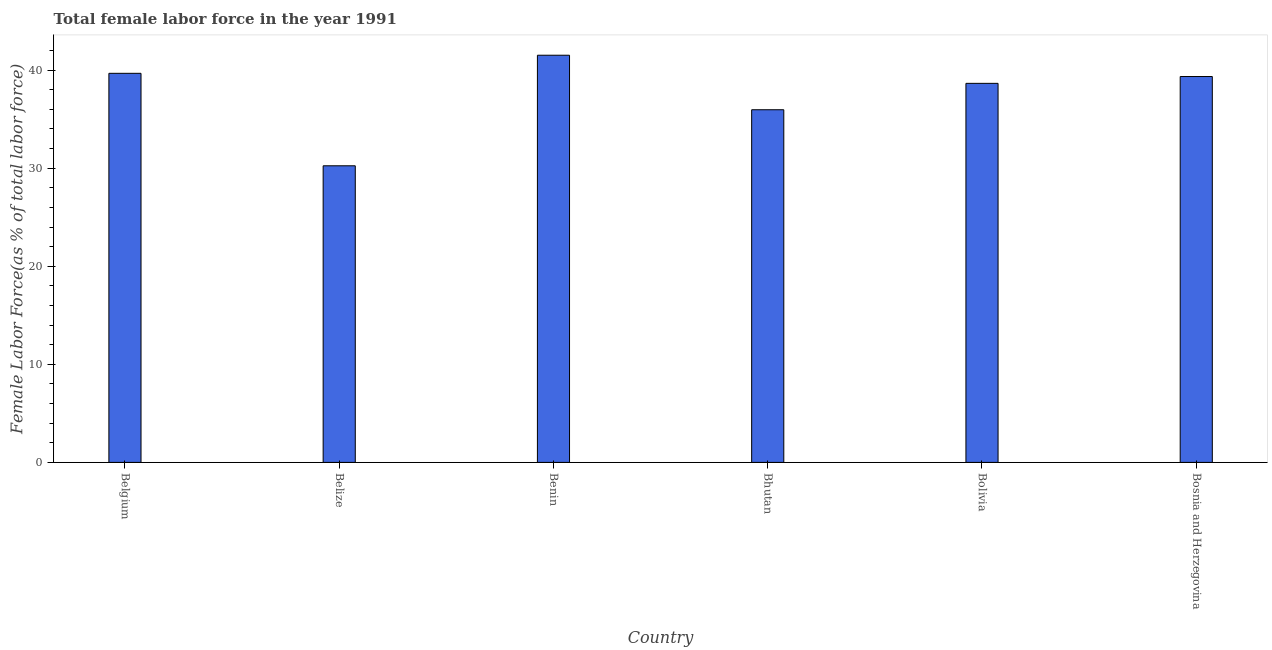Does the graph contain any zero values?
Provide a short and direct response. No. What is the title of the graph?
Make the answer very short. Total female labor force in the year 1991. What is the label or title of the Y-axis?
Give a very brief answer. Female Labor Force(as % of total labor force). What is the total female labor force in Belgium?
Offer a terse response. 39.68. Across all countries, what is the maximum total female labor force?
Make the answer very short. 41.52. Across all countries, what is the minimum total female labor force?
Provide a succinct answer. 30.24. In which country was the total female labor force maximum?
Offer a terse response. Benin. In which country was the total female labor force minimum?
Your answer should be very brief. Belize. What is the sum of the total female labor force?
Offer a terse response. 225.4. What is the difference between the total female labor force in Benin and Bosnia and Herzegovina?
Give a very brief answer. 2.17. What is the average total female labor force per country?
Keep it short and to the point. 37.57. What is the median total female labor force?
Make the answer very short. 39. What is the ratio of the total female labor force in Belgium to that in Bhutan?
Your answer should be very brief. 1.1. Is the difference between the total female labor force in Belize and Bhutan greater than the difference between any two countries?
Your answer should be compact. No. What is the difference between the highest and the second highest total female labor force?
Your response must be concise. 1.84. Is the sum of the total female labor force in Benin and Bhutan greater than the maximum total female labor force across all countries?
Provide a short and direct response. Yes. What is the difference between the highest and the lowest total female labor force?
Make the answer very short. 11.27. Are all the bars in the graph horizontal?
Your answer should be compact. No. Are the values on the major ticks of Y-axis written in scientific E-notation?
Your answer should be compact. No. What is the Female Labor Force(as % of total labor force) in Belgium?
Provide a short and direct response. 39.68. What is the Female Labor Force(as % of total labor force) in Belize?
Ensure brevity in your answer.  30.24. What is the Female Labor Force(as % of total labor force) of Benin?
Provide a short and direct response. 41.52. What is the Female Labor Force(as % of total labor force) of Bhutan?
Offer a terse response. 35.96. What is the Female Labor Force(as % of total labor force) of Bolivia?
Keep it short and to the point. 38.65. What is the Female Labor Force(as % of total labor force) in Bosnia and Herzegovina?
Give a very brief answer. 39.35. What is the difference between the Female Labor Force(as % of total labor force) in Belgium and Belize?
Ensure brevity in your answer.  9.43. What is the difference between the Female Labor Force(as % of total labor force) in Belgium and Benin?
Keep it short and to the point. -1.84. What is the difference between the Female Labor Force(as % of total labor force) in Belgium and Bhutan?
Your answer should be very brief. 3.71. What is the difference between the Female Labor Force(as % of total labor force) in Belgium and Bolivia?
Provide a short and direct response. 1.02. What is the difference between the Female Labor Force(as % of total labor force) in Belgium and Bosnia and Herzegovina?
Offer a terse response. 0.33. What is the difference between the Female Labor Force(as % of total labor force) in Belize and Benin?
Provide a short and direct response. -11.27. What is the difference between the Female Labor Force(as % of total labor force) in Belize and Bhutan?
Ensure brevity in your answer.  -5.72. What is the difference between the Female Labor Force(as % of total labor force) in Belize and Bolivia?
Make the answer very short. -8.41. What is the difference between the Female Labor Force(as % of total labor force) in Belize and Bosnia and Herzegovina?
Provide a succinct answer. -9.1. What is the difference between the Female Labor Force(as % of total labor force) in Benin and Bhutan?
Provide a succinct answer. 5.56. What is the difference between the Female Labor Force(as % of total labor force) in Benin and Bolivia?
Offer a very short reply. 2.87. What is the difference between the Female Labor Force(as % of total labor force) in Benin and Bosnia and Herzegovina?
Ensure brevity in your answer.  2.17. What is the difference between the Female Labor Force(as % of total labor force) in Bhutan and Bolivia?
Offer a very short reply. -2.69. What is the difference between the Female Labor Force(as % of total labor force) in Bhutan and Bosnia and Herzegovina?
Provide a short and direct response. -3.39. What is the difference between the Female Labor Force(as % of total labor force) in Bolivia and Bosnia and Herzegovina?
Your answer should be very brief. -0.7. What is the ratio of the Female Labor Force(as % of total labor force) in Belgium to that in Belize?
Ensure brevity in your answer.  1.31. What is the ratio of the Female Labor Force(as % of total labor force) in Belgium to that in Benin?
Make the answer very short. 0.96. What is the ratio of the Female Labor Force(as % of total labor force) in Belgium to that in Bhutan?
Keep it short and to the point. 1.1. What is the ratio of the Female Labor Force(as % of total labor force) in Belgium to that in Bolivia?
Your response must be concise. 1.03. What is the ratio of the Female Labor Force(as % of total labor force) in Belgium to that in Bosnia and Herzegovina?
Give a very brief answer. 1.01. What is the ratio of the Female Labor Force(as % of total labor force) in Belize to that in Benin?
Ensure brevity in your answer.  0.73. What is the ratio of the Female Labor Force(as % of total labor force) in Belize to that in Bhutan?
Make the answer very short. 0.84. What is the ratio of the Female Labor Force(as % of total labor force) in Belize to that in Bolivia?
Provide a short and direct response. 0.78. What is the ratio of the Female Labor Force(as % of total labor force) in Belize to that in Bosnia and Herzegovina?
Keep it short and to the point. 0.77. What is the ratio of the Female Labor Force(as % of total labor force) in Benin to that in Bhutan?
Provide a short and direct response. 1.16. What is the ratio of the Female Labor Force(as % of total labor force) in Benin to that in Bolivia?
Your answer should be compact. 1.07. What is the ratio of the Female Labor Force(as % of total labor force) in Benin to that in Bosnia and Herzegovina?
Provide a short and direct response. 1.05. What is the ratio of the Female Labor Force(as % of total labor force) in Bhutan to that in Bosnia and Herzegovina?
Your answer should be very brief. 0.91. What is the ratio of the Female Labor Force(as % of total labor force) in Bolivia to that in Bosnia and Herzegovina?
Your answer should be very brief. 0.98. 